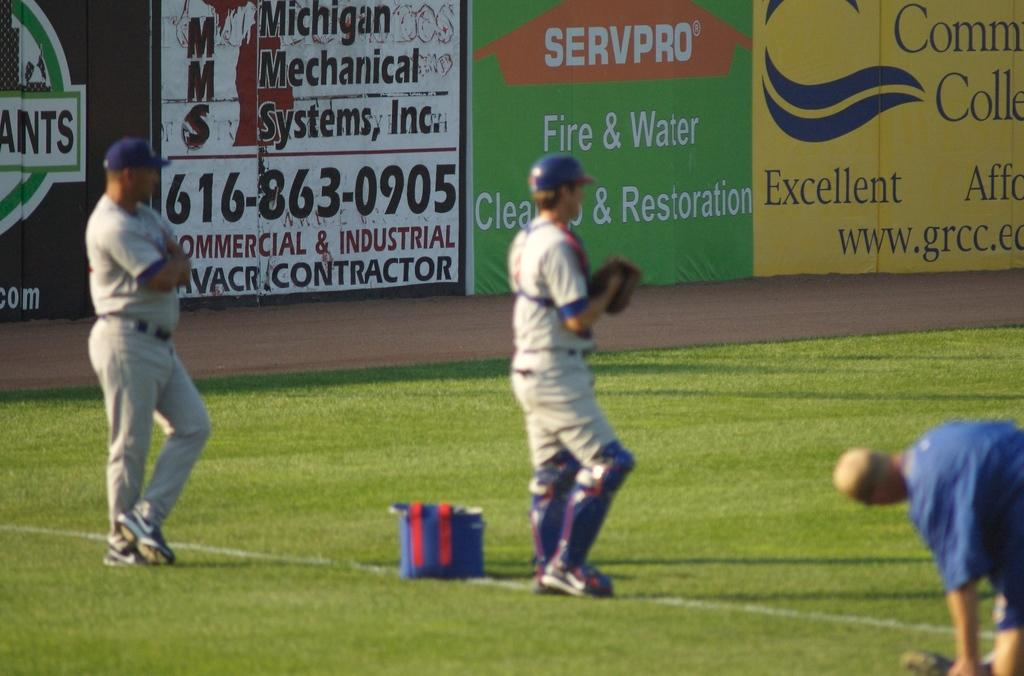<image>
Write a terse but informative summary of the picture. some players on a field practicing with an ad for fire and water nearby 